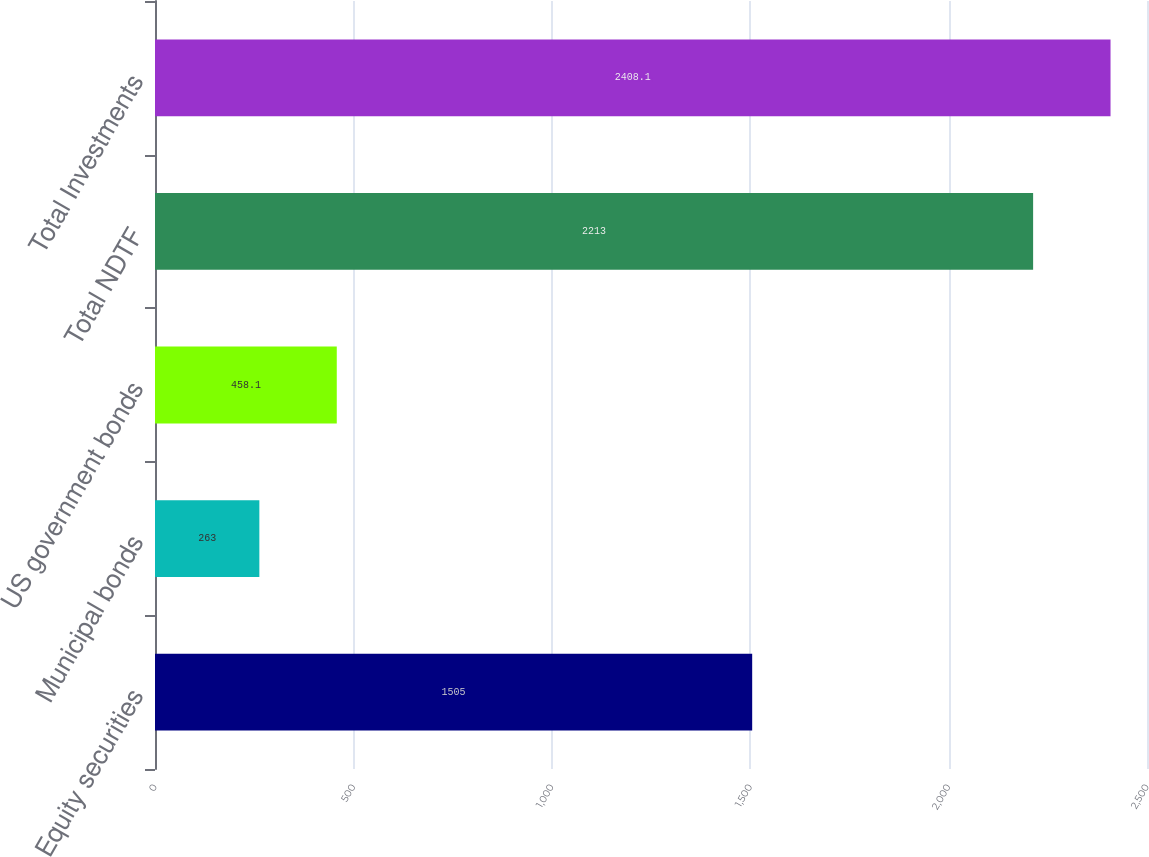<chart> <loc_0><loc_0><loc_500><loc_500><bar_chart><fcel>Equity securities<fcel>Municipal bonds<fcel>US government bonds<fcel>Total NDTF<fcel>Total Investments<nl><fcel>1505<fcel>263<fcel>458.1<fcel>2213<fcel>2408.1<nl></chart> 